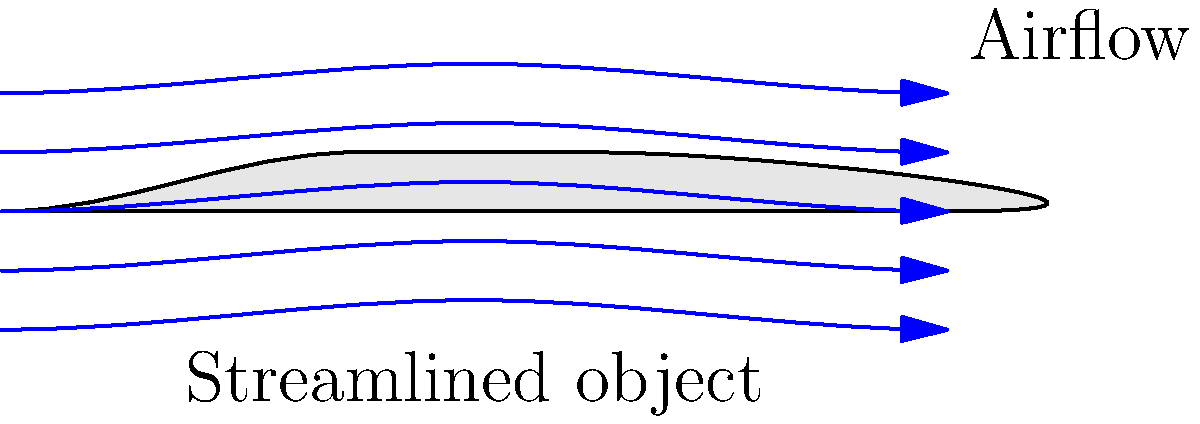In the context of aerodynamics, how does the shape of a streamlined object, like the one shown in the diagram, affect the airflow around it? How might this principle be applied to design elements in your Hellboy-inspired fan art or promotional event materials? To understand the airflow around a streamlined object, let's break it down step-by-step:

1. Shape analysis: The object in the diagram has a smooth, elongated shape with a rounded front and a tapered rear. This is typical of streamlined designs.

2. Airflow pattern: Notice how the blue arrows, representing airflow, smoothly curve around the object.

3. Leading edge: At the front of the object, the airflow lines spread out slightly. This indicates a small increase in pressure, but the rounded shape minimizes this effect.

4. Along the body: The airflow lines remain close to the object's surface, indicating attached flow. This is crucial for reducing drag.

5. Trailing edge: At the rear, the airflow lines converge smoothly. This smooth convergence minimizes the low-pressure wake behind the object.

6. Drag reduction: The streamlined shape helps maintain laminar flow (smooth, parallel layers of air) for as long as possible, delaying the transition to turbulent flow. This significantly reduces drag.

7. Pressure distribution: The shape creates a more even pressure distribution along the object, further reducing drag.

Application to Hellboy-inspired art and promotional materials:

1. Character design: You could incorporate streamlined elements into Hellboy's gear or vehicles to suggest enhanced speed or efficiency.

2. Logo design: A streamlined logo could convey a sense of speed or modernity for promotional events.

3. Background elements: Streamlined shapes in backgrounds could add a sense of motion or futuristic aesthetic to your fan art.

4. Promotional items: Design streamlined merchandise (e.g., pens, USB drives) that embody both the Hellboy aesthetic and aerodynamic principles.

By understanding and applying these aerodynamic principles, you can add an extra layer of scientific accuracy and visual interest to your Hellboy-inspired creations.
Answer: Streamlined shape reduces drag by maintaining smooth airflow, applicable to character/logo design and promotional items in Hellboy fan art. 